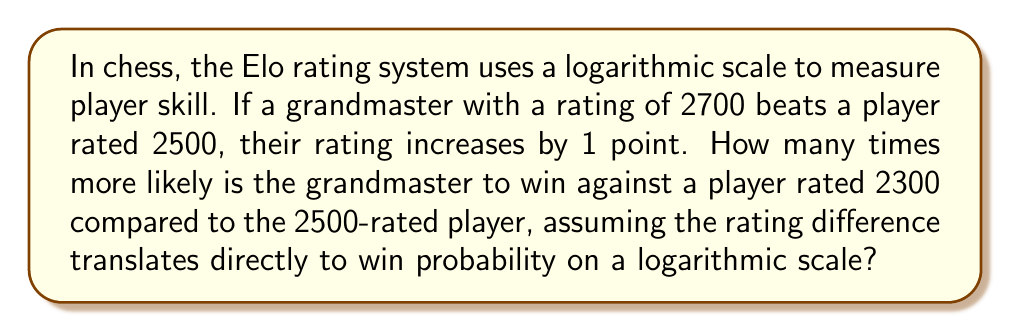Solve this math problem. Let's approach this step-by-step:

1) The Elo rating system uses a logistic function to calculate win probabilities. The difference in ratings is proportional to the logarithm of the odds ratio.

2) Let's define:
   $R_1 = 2700$ (Grandmaster's rating)
   $R_2 = 2500$ (First opponent's rating)
   $R_3 = 2300$ (Second opponent's rating)

3) The rating difference is proportional to the logarithm of the odds ratio. Let's call the constant of proportionality $k$. Then:

   $R_1 - R_2 = k \log(\frac{P_1}{1-P_1})$
   $R_1 - R_3 = k \log(\frac{P_2}{1-P_2})$

   Where $P_1$ and $P_2$ are the probabilities of the grandmaster winning against the 2500 and 2300 rated players respectively.

4) We're told that $R_1 - R_2 = 200$ corresponds to a 1 point increase, which we can assume means a very small increase in win probability. Let's say this corresponds to odds of 2:1. Then:

   $200 = k \log(2)$
   $k = \frac{200}{\log(2)}$

5) Now we can calculate the odds for the 400 point difference:

   $400 = \frac{200}{\log(2)} \log(\frac{P_2}{1-P_2})$
   $\log(\frac{P_2}{1-P_2}) = 2\log(2)$
   $\frac{P_2}{1-P_2} = 2^2 = 4$

6) This means the odds of the grandmaster winning against the 2300-rated player are 4:1.

7) Compared to the 2:1 odds against the 2500-rated player, this is twice as likely.
Answer: 2 times 